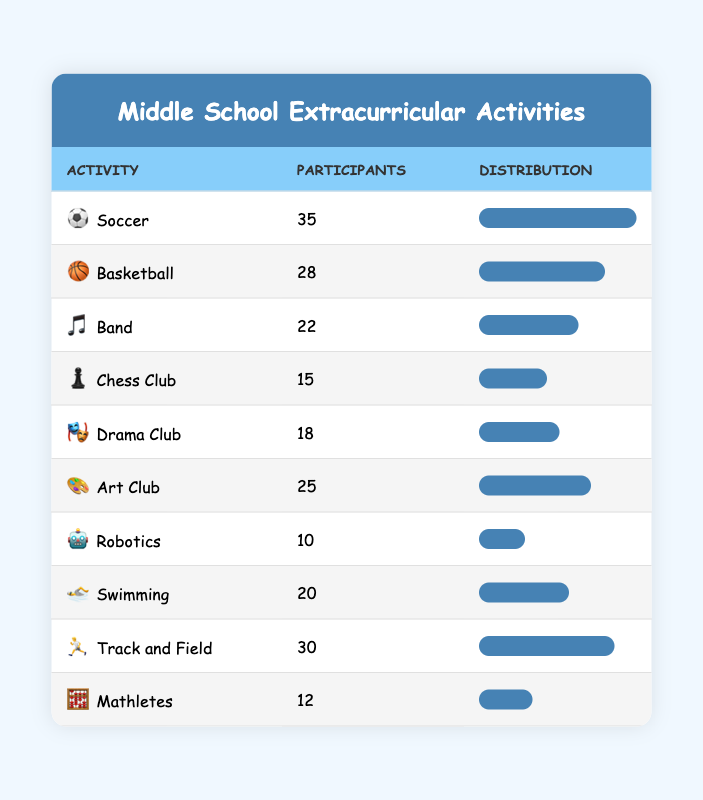What is the total number of participants in all extracurricular activities? To find the total number of participants, we sum all participants: 35 (Soccer) + 28 (Basketball) + 22 (Band) + 15 (Chess Club) + 18 (Drama Club) + 25 (Art Club) + 10 (Robotics) + 20 (Swimming) + 30 (Track and Field) + 12 (Mathletes) =  35 + 28 + 22 + 15 + 18 + 25 + 10 + 20 + 30 + 12 =  270.
Answer: 270 Which activity has the highest number of participants? By visually inspecting the table, Soccer has 35 participants, which is more than any other activity.
Answer: Soccer Is the number of participants in the Art Club greater than in the Drama Club? Art Club has 25 participants while Drama Club has 18 participants. 25 is greater than 18, therefore the statement is true.
Answer: Yes How many more participants are there in Track and Field than in Basketball? The number of participants in Track and Field is 30 and in Basketball is 28. The difference is calculated as 30 - 28 = 2.
Answer: 2 What is the average number of participants across all the activities? The average is calculated by taking the total number of participants (270) and dividing it by the number of activities (10): 270 / 10 = 27.
Answer: 27 Is there any activity that has exactly 15 participants? Looking at the table, Chess Club has 15 participants, confirming that there is an activity with this number.
Answer: Yes Name two activities that have less than 20 participants. From the table, Robotics with 10 participants and Chess Club with 15 participants both have fewer than 20 participants.
Answer: Robotics and Chess Club Which two activities have the closest number of participants? By comparing the numbers, Drama Club has 18 participants and Swimming has 20 participants. The difference is 2, which is the smallest difference among the numbers.
Answer: Drama Club and Swimming 